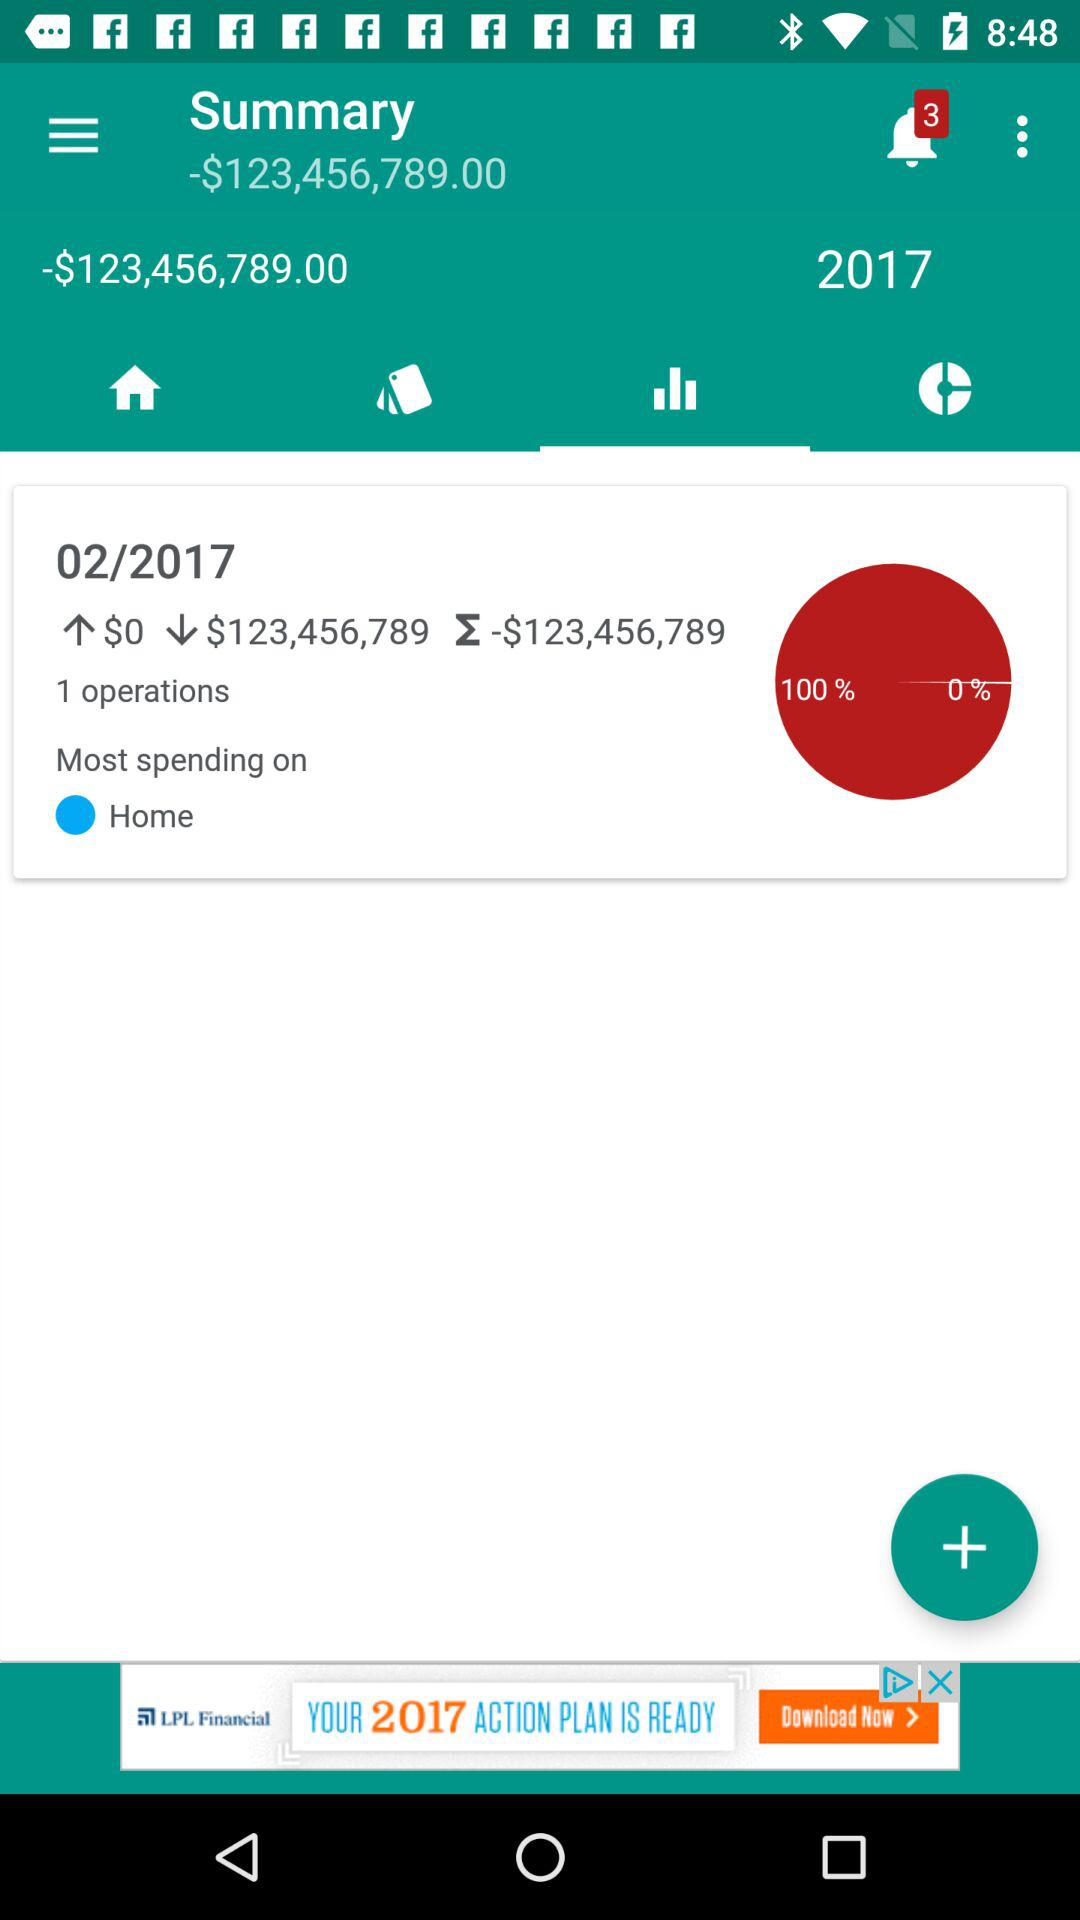What is the total amount of money spent this year?
Answer the question using a single word or phrase. -$123,456,789.00 